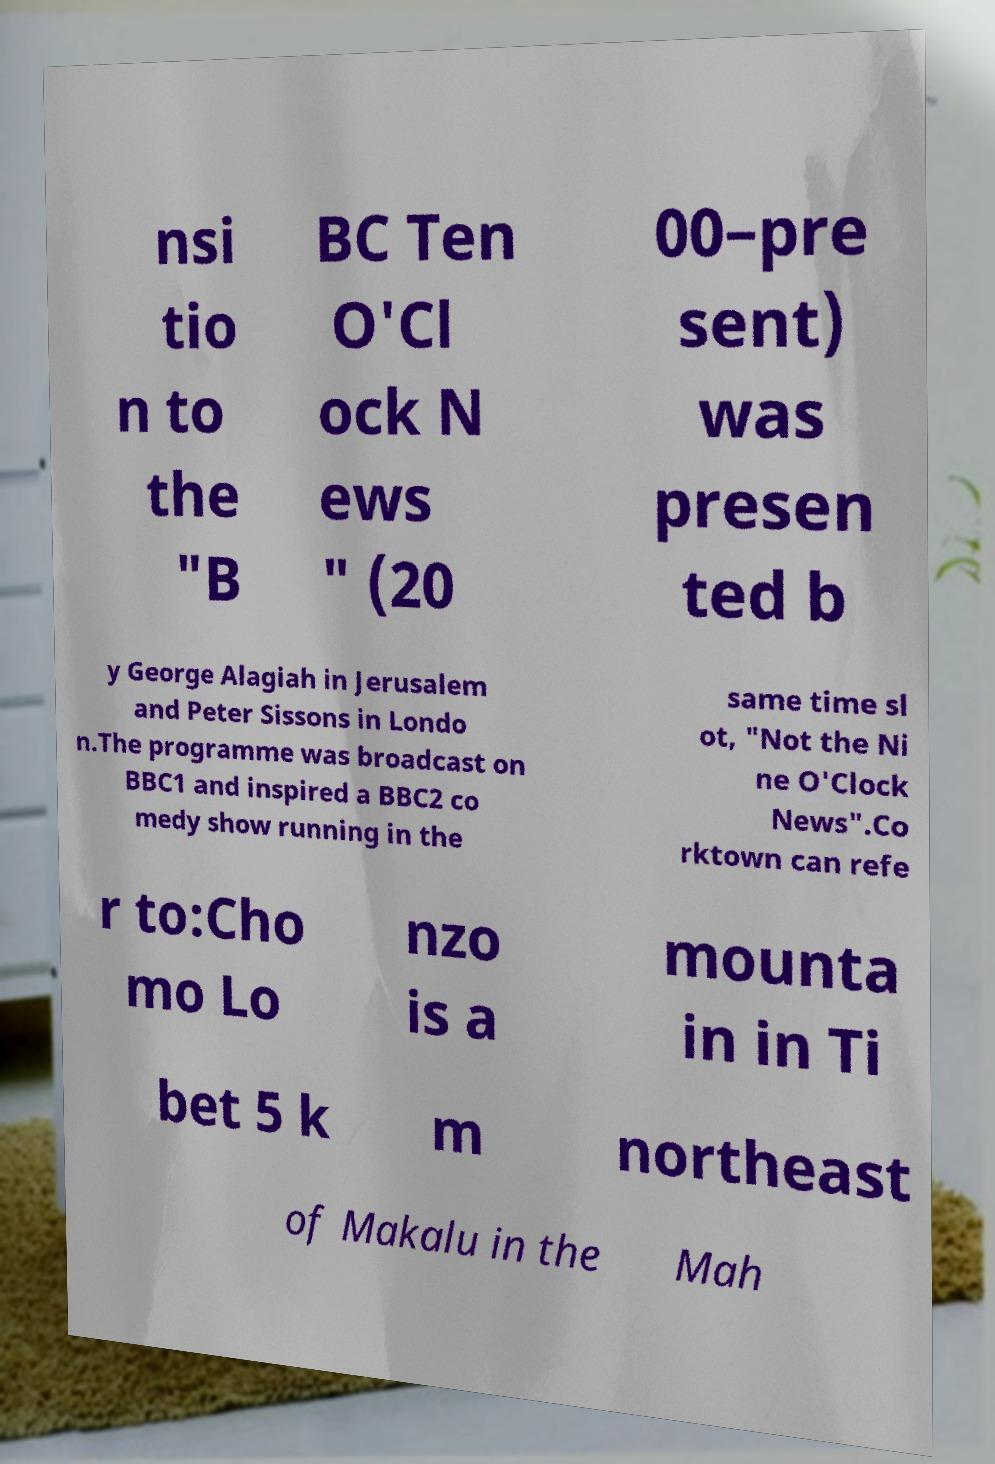Could you assist in decoding the text presented in this image and type it out clearly? nsi tio n to the "B BC Ten O'Cl ock N ews " (20 00–pre sent) was presen ted b y George Alagiah in Jerusalem and Peter Sissons in Londo n.The programme was broadcast on BBC1 and inspired a BBC2 co medy show running in the same time sl ot, "Not the Ni ne O'Clock News".Co rktown can refe r to:Cho mo Lo nzo is a mounta in in Ti bet 5 k m northeast of Makalu in the Mah 